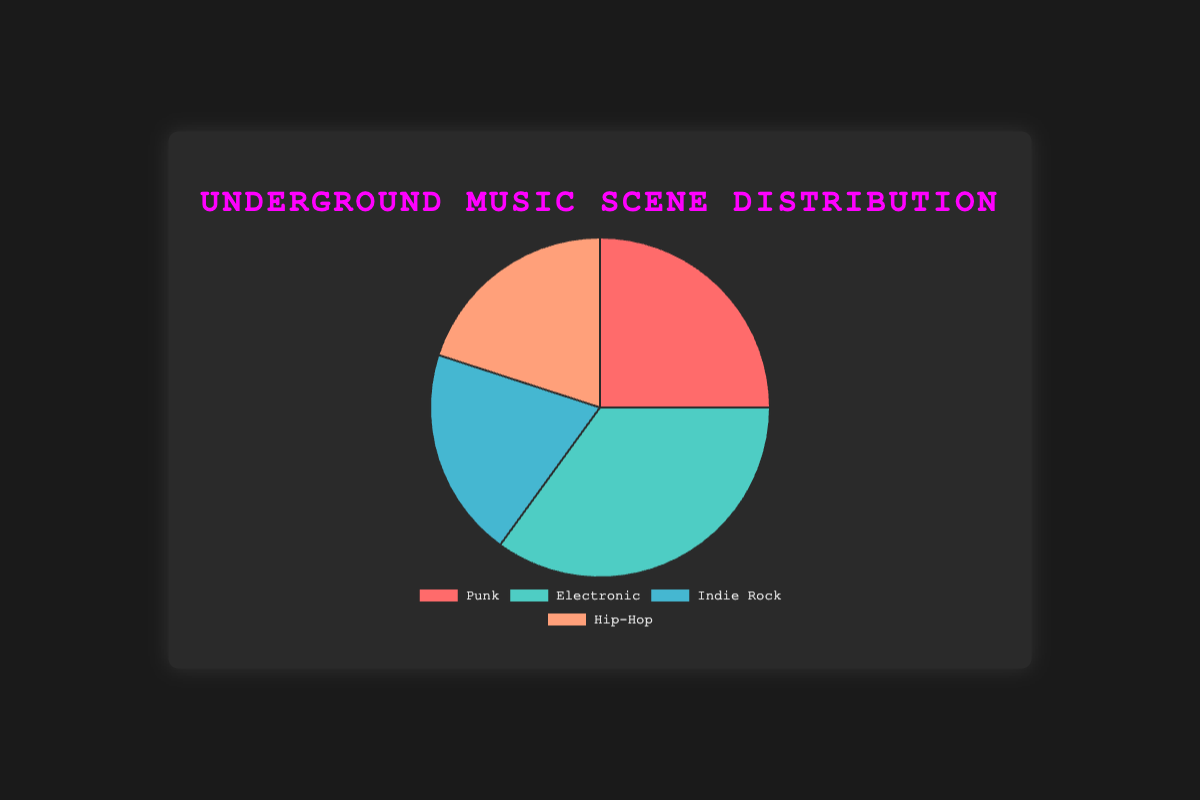Which music genre has the highest representation in the underground scene? The genre with the highest percentage is the one that holds the largest slice of the pie chart. According to the chart, Electronic music has the highest representation.
Answer: Electronic What's the combined percentage of Indie Rock and Hip-Hop in the underground scene? To find the combined percentage, add the percentages of Indie Rock and Hip-Hop. Indie Rock is 20%, and Hip-Hop is 20%. So, 20 + 20 = 40%.
Answer: 40% Compare the percentage representation between Punk and Electronic genres. Which one is greater and by how much? Electronic music (35%) has a greater representation than Punk (25%). To find by how much, subtract Punk's percentage from Electronic's: 35 - 25 = 10%.
Answer: Electronic, by 10% What percentage of the underground music scene do punk and Indie Rock genres make up together? Add the percentages of Punk (25%) and Indie Rock (20%). So, 25 + 20 = 45%.
Answer: 45% How does the representation of Hip-Hop compare to Punk in the underground music scene? Punk has a percentage of 25%, while Hip-Hop has 20%. Since 25% is greater than 20%, Punk has a higher representation.
Answer: Punk has a higher representation If a new genre were introduced, and its representation was equal to the average of the current four genres, what would its percentage be? Calculate the average by summing the percentages of all genres and dividing by 4: (25 + 35 + 20 + 20) / 4 = 100 / 4 = 25%.
Answer: 25% What is the difference in percentage representation between the least represented genre and the most represented genre? The most represented genre is Electronic at 35%, and the least represented (Indie Rock and Hip-Hop) is at 20%. The difference is 35 - 20 = 15%.
Answer: 15% Identify the genre with the second highest representation and any key artists associated with this genre. The second highest representation is Punk with 25%. Some notable artists are The Exploited, Bad Religion, and Dead Kennedys.
Answer: Punk; The Exploited, Bad Religion, Dead Kennedys If the percentage of Indie Rock were doubled, what would be its new representation and how would it compare to Electronic? Doubling Indie Rock's percentage (20%) gives 20 x 2 = 40%. This would make Indie Rock (40%) have a higher representation than Electronic (35%).
Answer: 40%; Higher than Electronic What color is used to represent Hip-Hop on the chart? The visual attribute for Hip-Hop shows it represented by the color orange.
Answer: Orange 